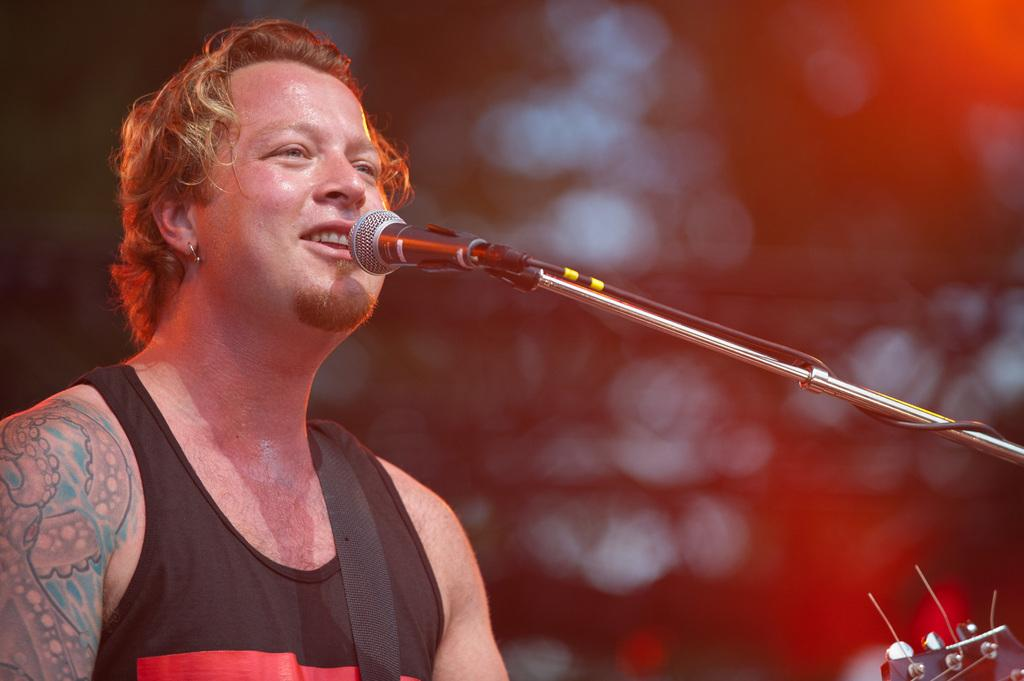What is the main subject on the left side of the image? There is a person standing on the left side of the image. What object is located in the middle of the image? There is a microphone (Mic) in the middle of the image. What type of fork is being used by the person in the image? There is no fork present in the image; the person is standing near a microphone. How does the person's memory affect the image? The person's memory is not visible or relevant in the image, as it only shows a person standing near a microphone. 